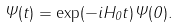<formula> <loc_0><loc_0><loc_500><loc_500>\Psi ( t ) = \exp ( - i H _ { 0 } t ) \Psi ( 0 ) .</formula> 